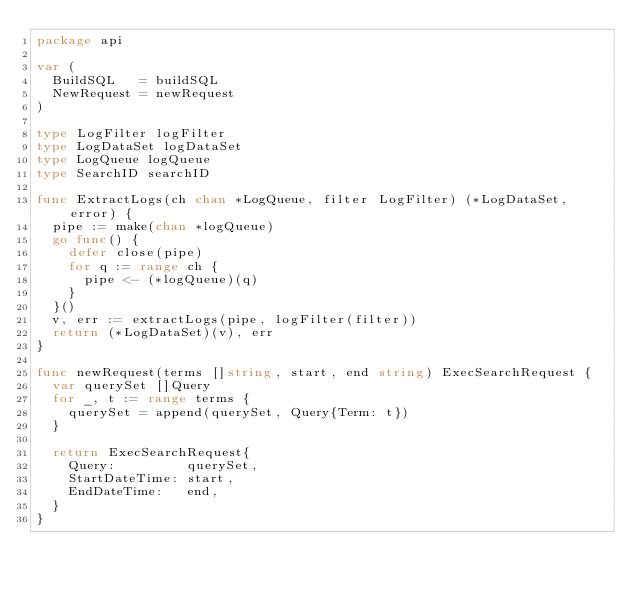<code> <loc_0><loc_0><loc_500><loc_500><_Go_>package api

var (
	BuildSQL   = buildSQL
	NewRequest = newRequest
)

type LogFilter logFilter
type LogDataSet logDataSet
type LogQueue logQueue
type SearchID searchID

func ExtractLogs(ch chan *LogQueue, filter LogFilter) (*LogDataSet, error) {
	pipe := make(chan *logQueue)
	go func() {
		defer close(pipe)
		for q := range ch {
			pipe <- (*logQueue)(q)
		}
	}()
	v, err := extractLogs(pipe, logFilter(filter))
	return (*LogDataSet)(v), err
}

func newRequest(terms []string, start, end string) ExecSearchRequest {
	var querySet []Query
	for _, t := range terms {
		querySet = append(querySet, Query{Term: t})
	}

	return ExecSearchRequest{
		Query:         querySet,
		StartDateTime: start,
		EndDateTime:   end,
	}
}
</code> 